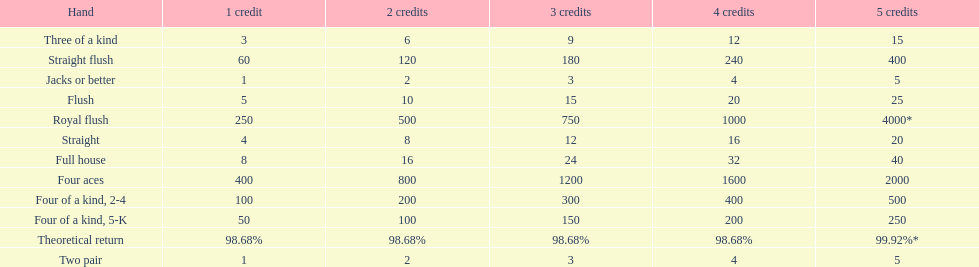What is the total amount of a 3 credit straight flush? 180. 